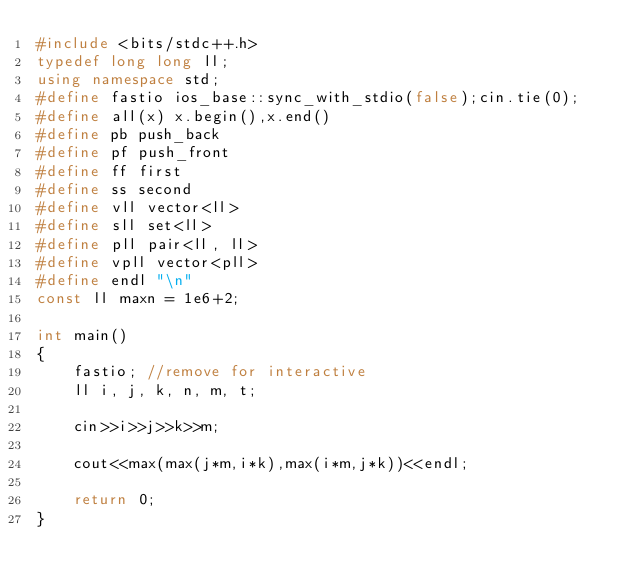Convert code to text. <code><loc_0><loc_0><loc_500><loc_500><_C++_>#include <bits/stdc++.h>
typedef long long ll;
using namespace std;
#define fastio ios_base::sync_with_stdio(false);cin.tie(0);
#define all(x) x.begin(),x.end()
#define pb push_back
#define pf push_front
#define ff first
#define ss second
#define vll vector<ll>
#define sll set<ll>
#define pll pair<ll, ll>
#define vpll vector<pll>
#define endl "\n"
const ll maxn = 1e6+2;

int main()
{
    fastio; //remove for interactive
    ll i, j, k, n, m, t;

    cin>>i>>j>>k>>m;

    cout<<max(max(j*m,i*k),max(i*m,j*k))<<endl;

    return 0;
}</code> 